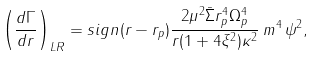<formula> <loc_0><loc_0><loc_500><loc_500>\left ( \frac { d \Gamma } { d r } \right ) _ { L R } = s i g n ( r - r _ { p } ) \frac { 2 \mu ^ { 2 } \bar { \Sigma } r _ { p } ^ { 4 } \Omega _ { p } ^ { 4 } } { r ( 1 + 4 \xi ^ { 2 } ) \kappa ^ { 2 } } \, m ^ { 4 } \, \psi ^ { 2 } ,</formula> 